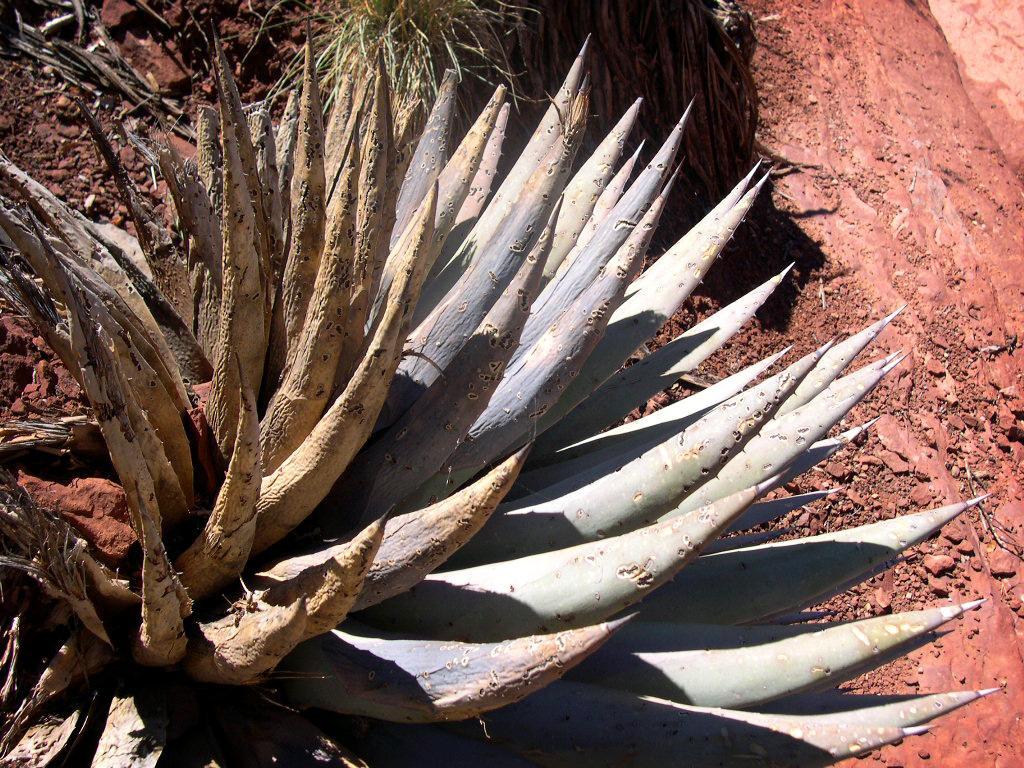Describe this image in one or two sentences. In this image I can see the plants and grass. To the side I can see the brown color rock. 